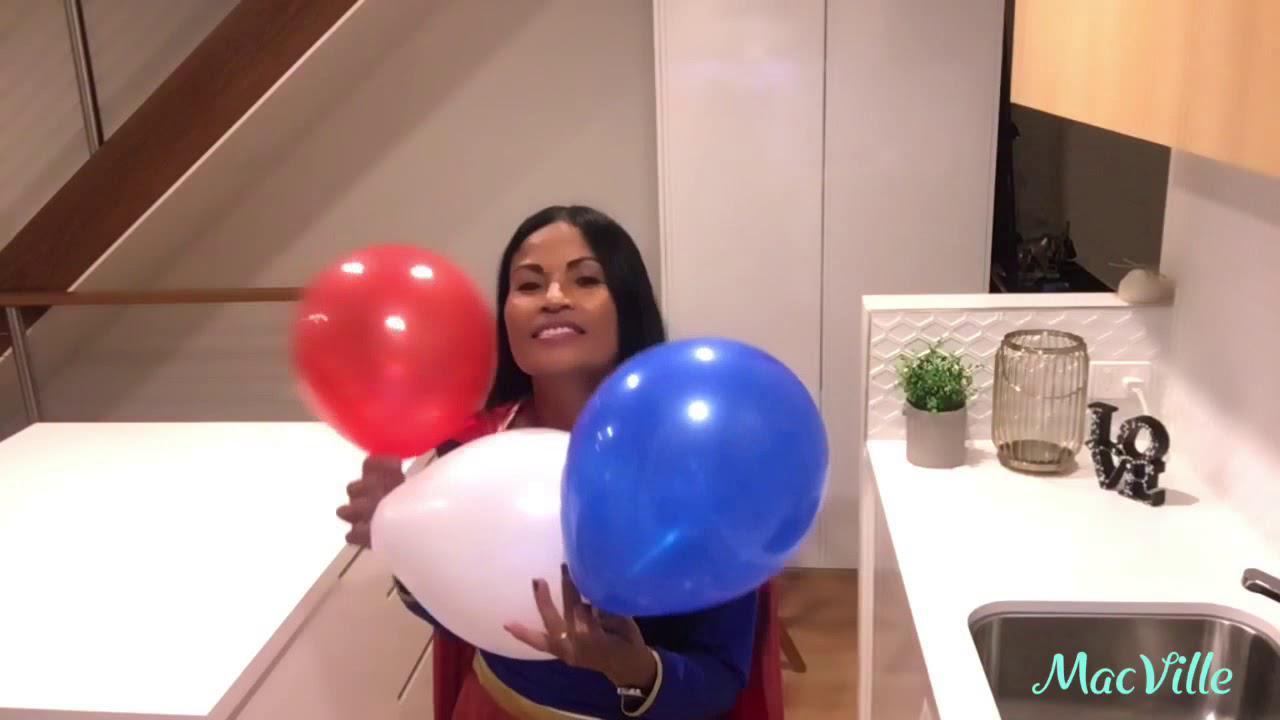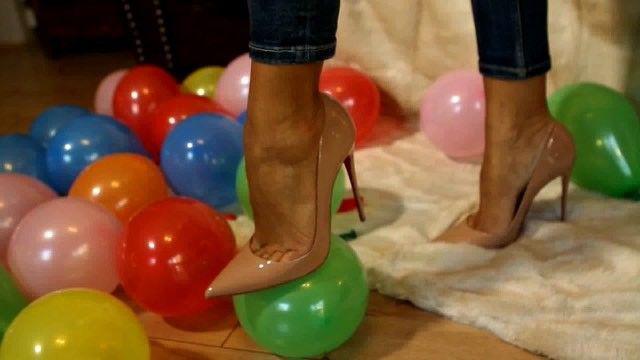The first image is the image on the left, the second image is the image on the right. Analyze the images presented: Is the assertion "The right image shows a foot in a stilleto heeled shoe above a green balloon, with various colors of balloons around it on the floor." valid? Answer yes or no. Yes. The first image is the image on the left, the second image is the image on the right. Examine the images to the left and right. Is the description "In at least one image there is a woman with a pair of high heels above a balloon." accurate? Answer yes or no. Yes. 